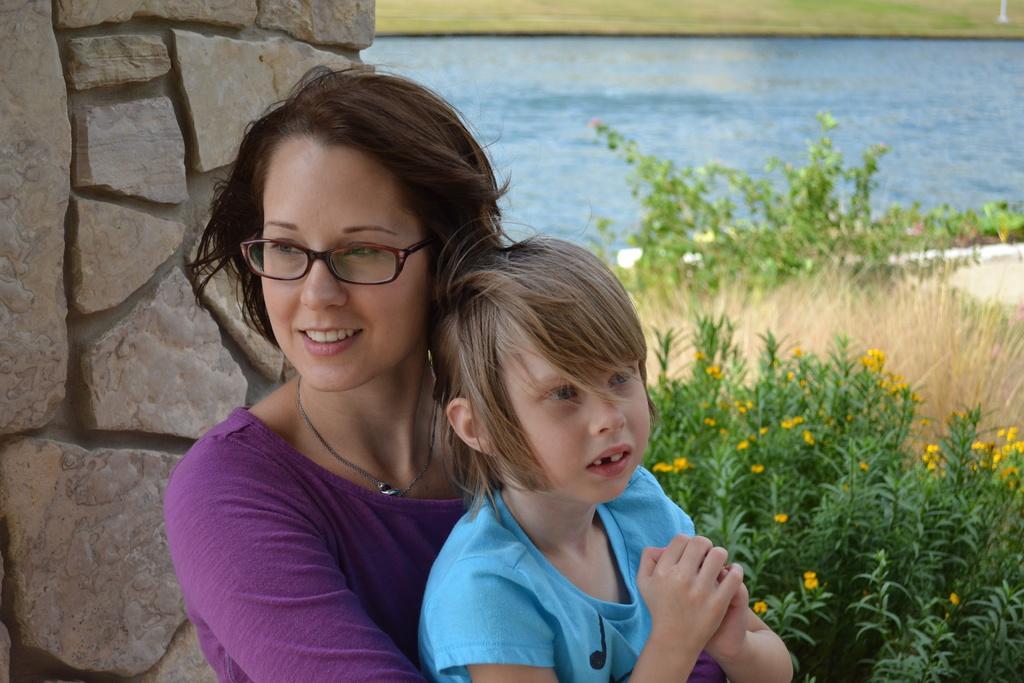Please provide a concise description of this image. In this image in the foreground there is one woman and one girl women is wearing spectacles, and on the left side there is a wall. And on the right side there are some plants, flowers and there is a beach and grass. 